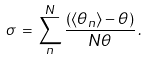<formula> <loc_0><loc_0><loc_500><loc_500>\sigma \, = \, \sum _ { n } ^ { N } \frac { ( \langle \theta _ { n } \rangle - \theta ) } { N \theta } \, .</formula> 